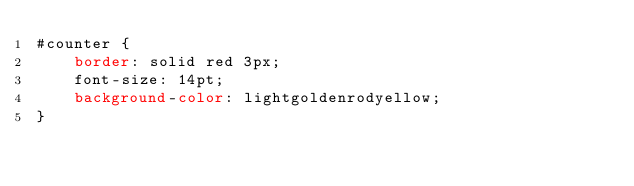Convert code to text. <code><loc_0><loc_0><loc_500><loc_500><_CSS_>#counter {
    border: solid red 3px;
    font-size: 14pt;
    background-color: lightgoldenrodyellow;
}
</code> 